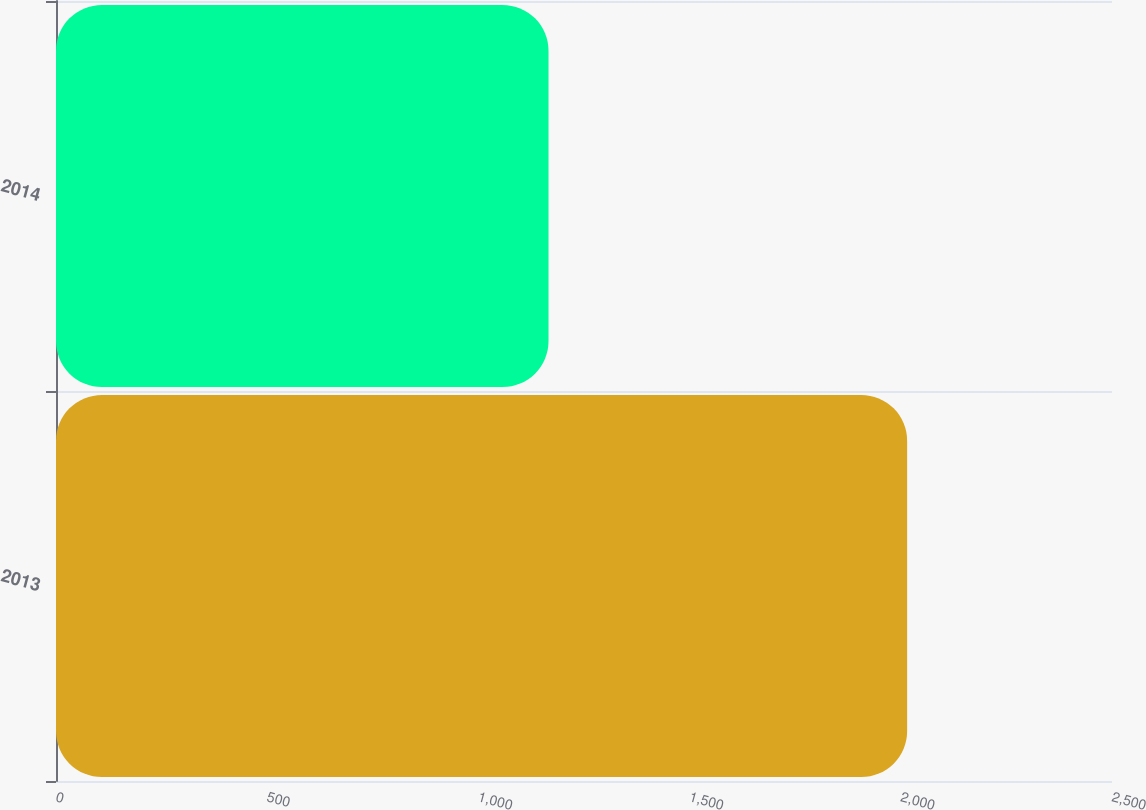<chart> <loc_0><loc_0><loc_500><loc_500><bar_chart><fcel>2013<fcel>2014<nl><fcel>2015<fcel>1166<nl></chart> 